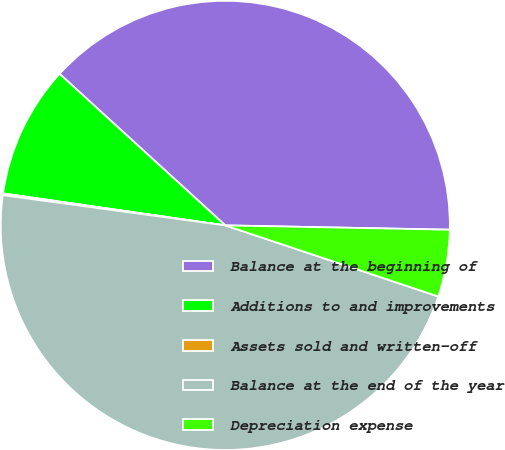Convert chart. <chart><loc_0><loc_0><loc_500><loc_500><pie_chart><fcel>Balance at the beginning of<fcel>Additions to and improvements<fcel>Assets sold and written-off<fcel>Balance at the end of the year<fcel>Depreciation expense<nl><fcel>38.52%<fcel>9.51%<fcel>0.13%<fcel>47.02%<fcel>4.82%<nl></chart> 